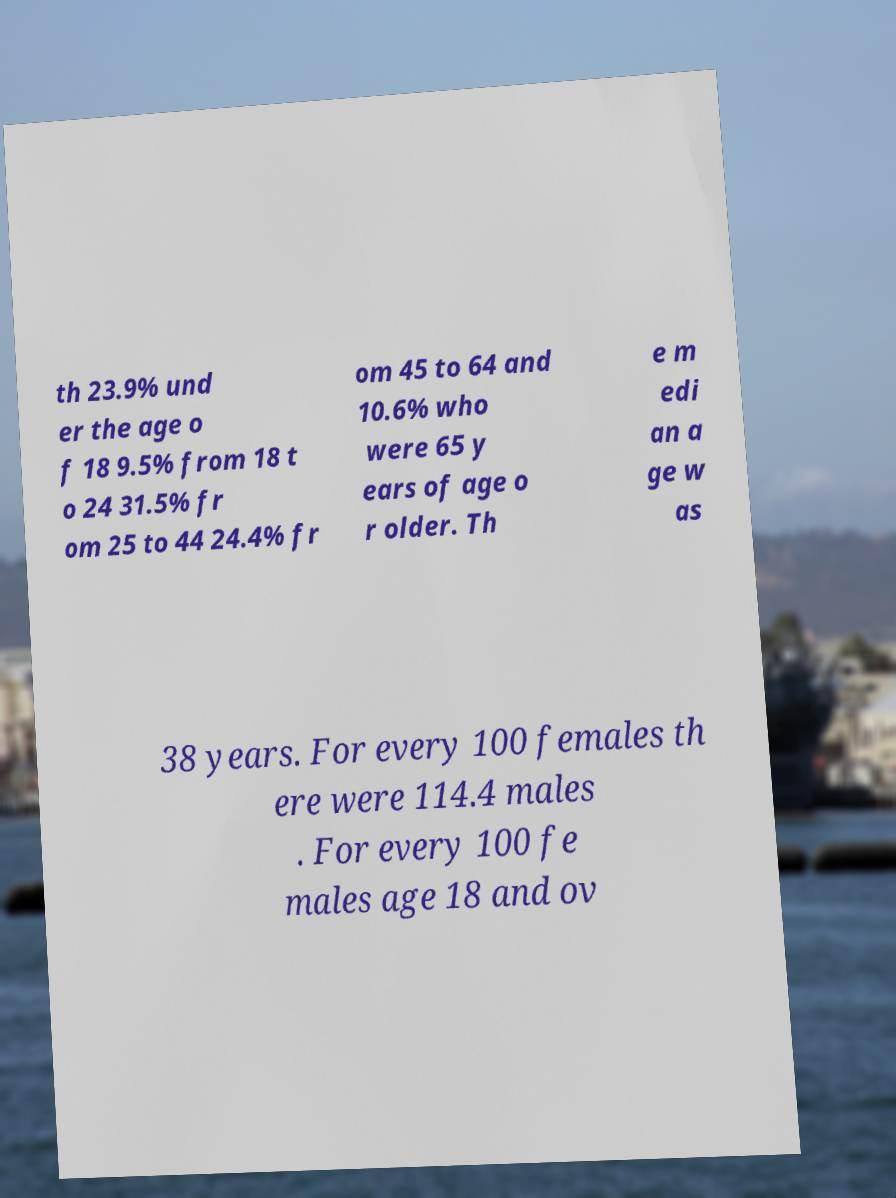Please identify and transcribe the text found in this image. th 23.9% und er the age o f 18 9.5% from 18 t o 24 31.5% fr om 25 to 44 24.4% fr om 45 to 64 and 10.6% who were 65 y ears of age o r older. Th e m edi an a ge w as 38 years. For every 100 females th ere were 114.4 males . For every 100 fe males age 18 and ov 